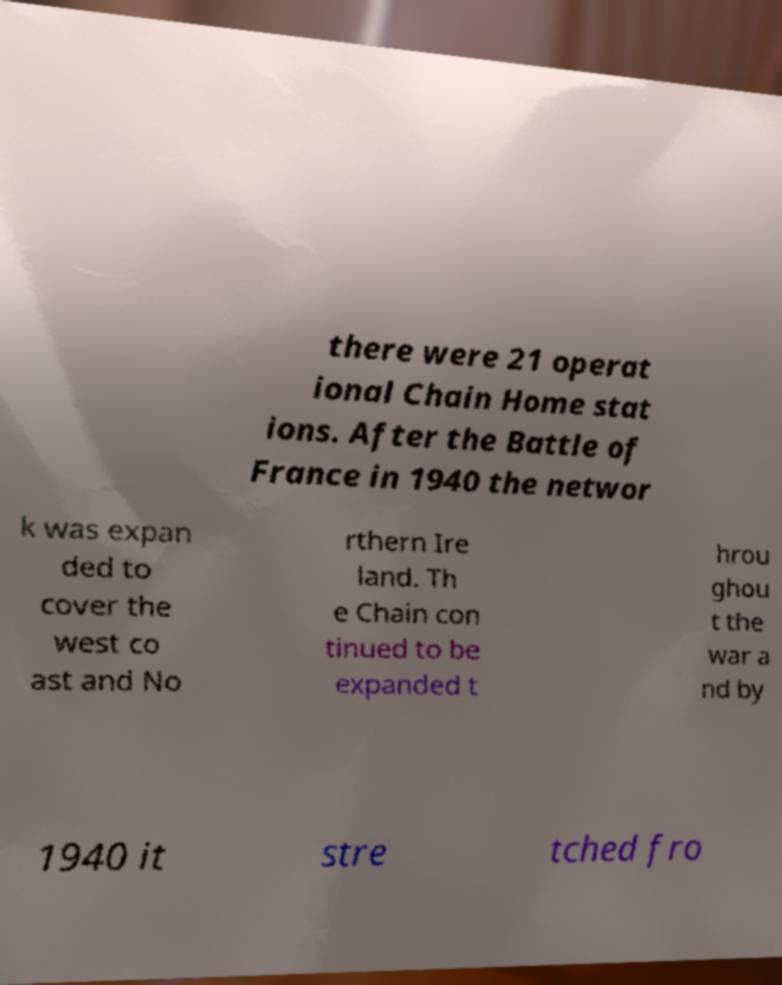What messages or text are displayed in this image? I need them in a readable, typed format. there were 21 operat ional Chain Home stat ions. After the Battle of France in 1940 the networ k was expan ded to cover the west co ast and No rthern Ire land. Th e Chain con tinued to be expanded t hrou ghou t the war a nd by 1940 it stre tched fro 